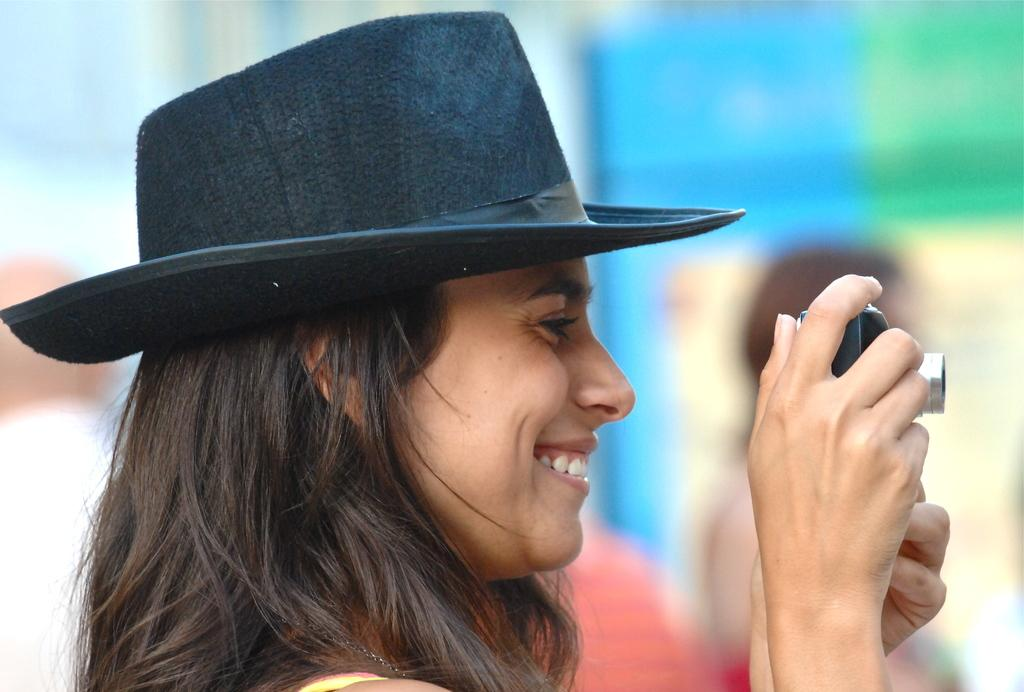What is the main subject of the image? There is a person in the image. How is the person depicted in the image? The person is truncated towards the bottom of the image. What is the person wearing in the image? The person is wearing a hat. What is the person holding in the image? The person is holding a camera. Can you describe the background of the image? The background of the image is blurred. What type of queen is present in the image? There is no queen present in the image; it features a person holding a camera. Can you tell me how many times the person bites into the camera in the image? There is no indication of the person biting into the camera in the image. 